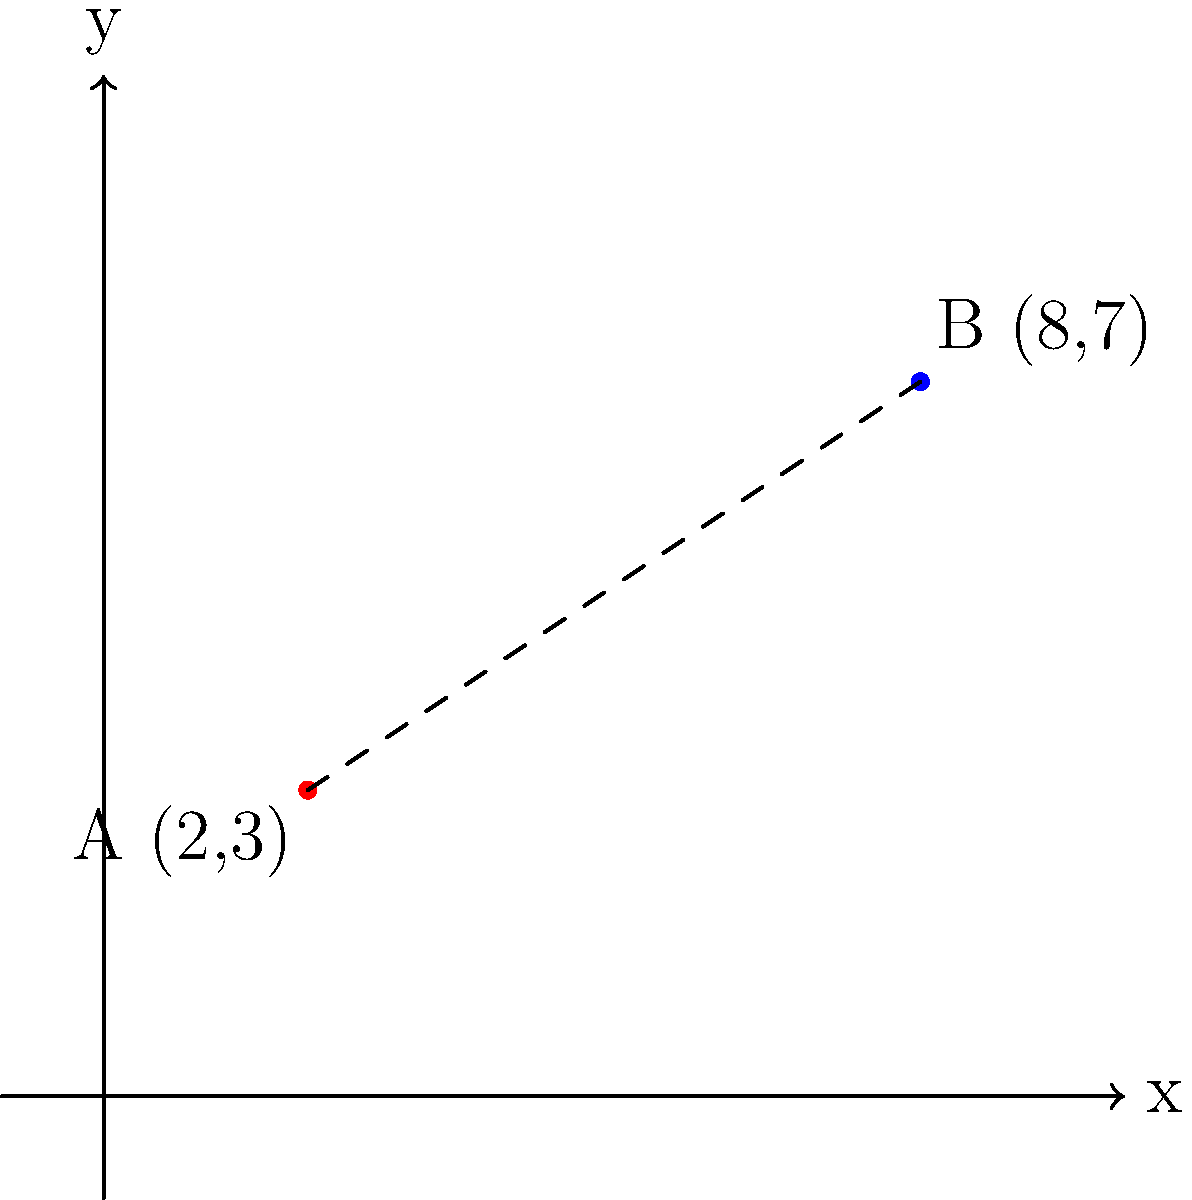Two military outposts, A and B, are located on a tactical map using Cartesian coordinates. Outpost A is at coordinates (2,3) and Outpost B is at (8,7). Calculate the straight-line distance between these two outposts to the nearest tenth of a unit. Assume each unit on the map represents 1 kilometer on the ground. To solve this problem, we'll use the distance formula derived from the Pythagorean theorem:

1) The distance formula is: 
   $$d = \sqrt{(x_2-x_1)^2 + (y_2-y_1)^2}$$

2) We have:
   Outpost A: $(x_1,y_1) = (2,3)$
   Outpost B: $(x_2,y_2) = (8,7)$

3) Let's substitute these into the formula:
   $$d = \sqrt{(8-2)^2 + (7-3)^2}$$

4) Simplify inside the parentheses:
   $$d = \sqrt{6^2 + 4^2}$$

5) Calculate the squares:
   $$d = \sqrt{36 + 16}$$

6) Add inside the square root:
   $$d = \sqrt{52}$$

7) Calculate the square root:
   $$d \approx 7.2111$$

8) Rounding to the nearest tenth:
   $$d \approx 7.2$$

Therefore, the straight-line distance between the two outposts is approximately 7.2 units, or 7.2 kilometers on the ground.
Answer: 7.2 km 